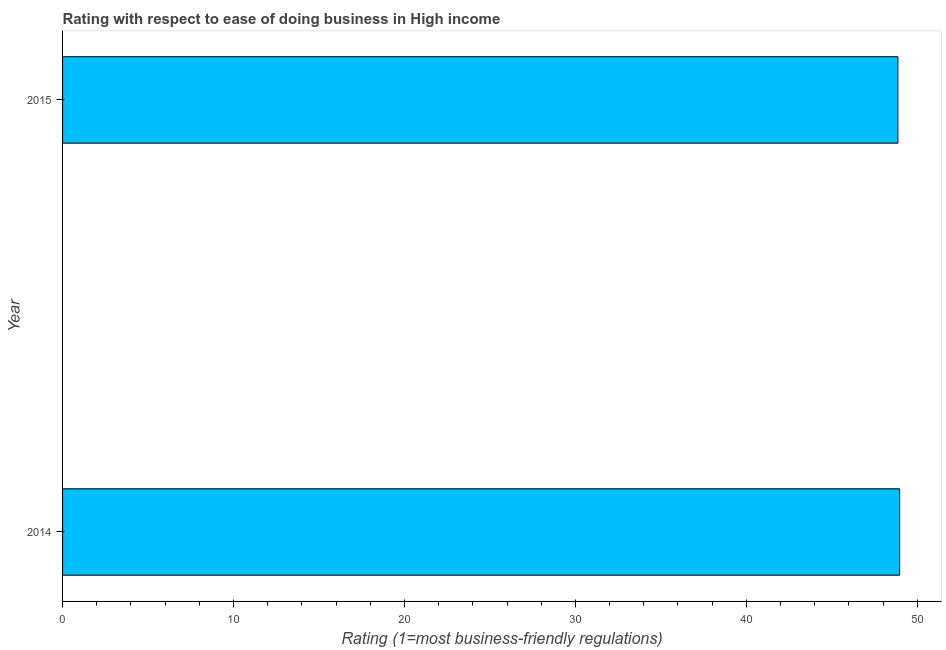Does the graph contain any zero values?
Provide a short and direct response. No. What is the title of the graph?
Offer a very short reply. Rating with respect to ease of doing business in High income. What is the label or title of the X-axis?
Keep it short and to the point. Rating (1=most business-friendly regulations). What is the label or title of the Y-axis?
Keep it short and to the point. Year. What is the ease of doing business index in 2014?
Make the answer very short. 48.97. Across all years, what is the maximum ease of doing business index?
Give a very brief answer. 48.97. Across all years, what is the minimum ease of doing business index?
Make the answer very short. 48.87. In which year was the ease of doing business index maximum?
Give a very brief answer. 2014. In which year was the ease of doing business index minimum?
Provide a short and direct response. 2015. What is the sum of the ease of doing business index?
Make the answer very short. 97.83. What is the average ease of doing business index per year?
Ensure brevity in your answer.  48.92. What is the median ease of doing business index?
Offer a very short reply. 48.92. What is the ratio of the ease of doing business index in 2014 to that in 2015?
Make the answer very short. 1. Is the ease of doing business index in 2014 less than that in 2015?
Keep it short and to the point. No. Are the values on the major ticks of X-axis written in scientific E-notation?
Give a very brief answer. No. What is the Rating (1=most business-friendly regulations) of 2014?
Provide a short and direct response. 48.97. What is the Rating (1=most business-friendly regulations) in 2015?
Your answer should be compact. 48.87. What is the ratio of the Rating (1=most business-friendly regulations) in 2014 to that in 2015?
Provide a short and direct response. 1. 